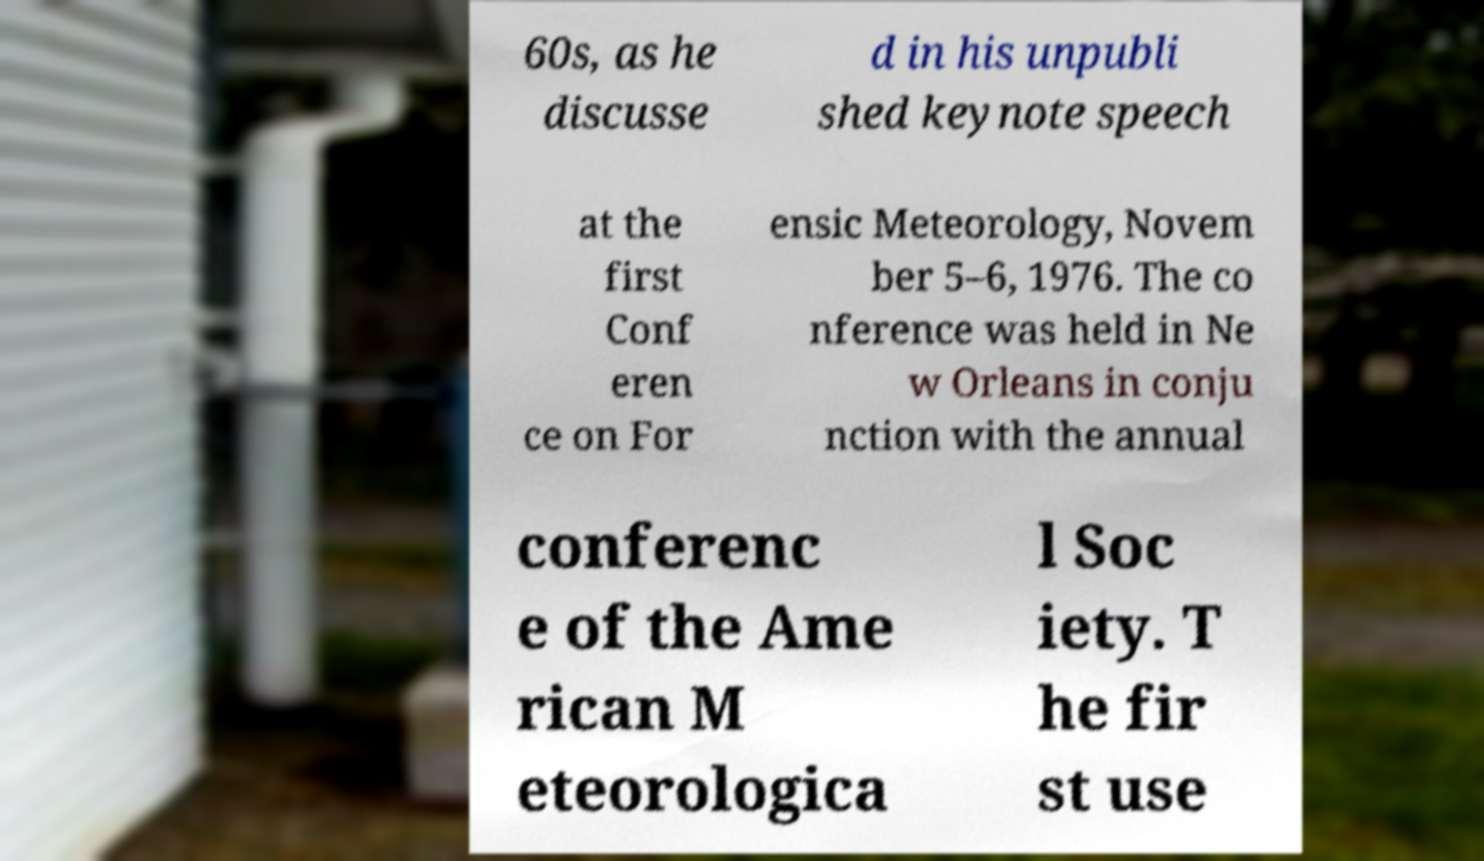Please identify and transcribe the text found in this image. 60s, as he discusse d in his unpubli shed keynote speech at the first Conf eren ce on For ensic Meteorology, Novem ber 5–6, 1976. The co nference was held in Ne w Orleans in conju nction with the annual conferenc e of the Ame rican M eteorologica l Soc iety. T he fir st use 